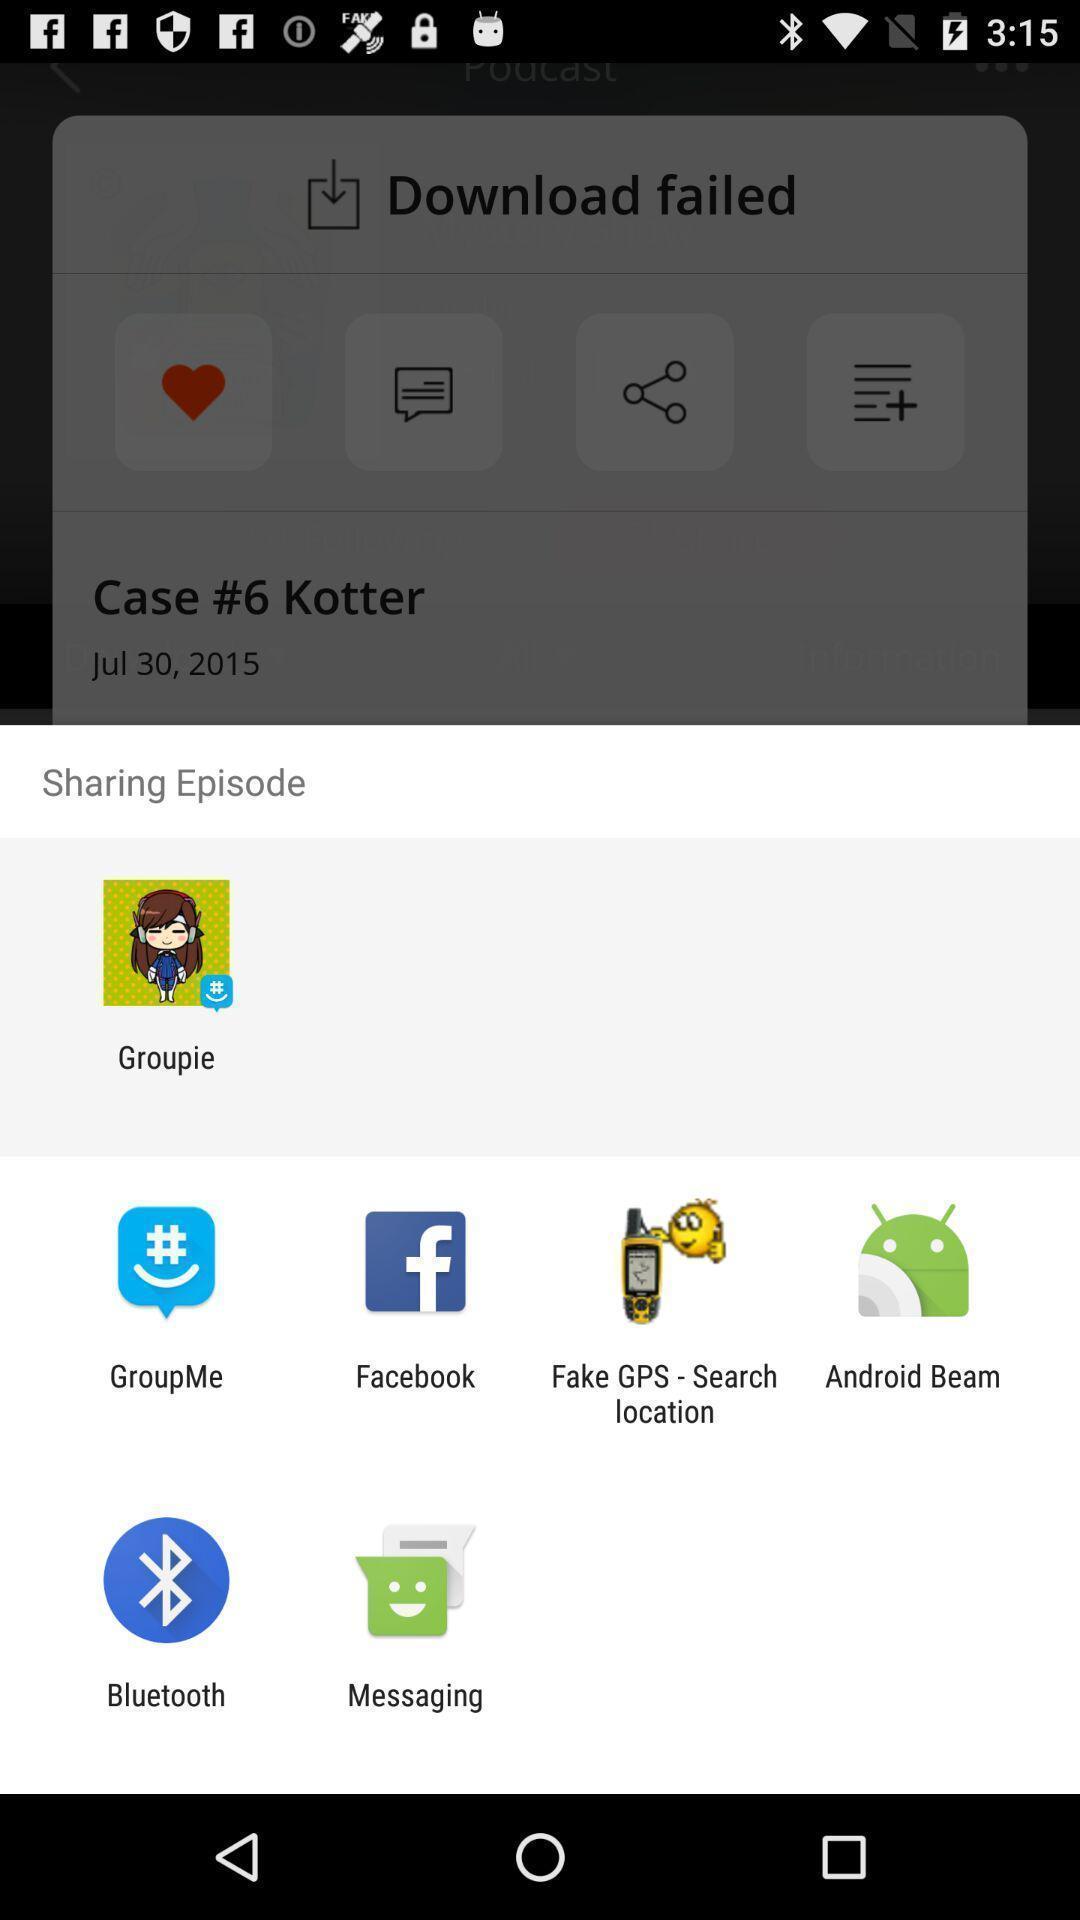What can you discern from this picture? Share episode through social app. 